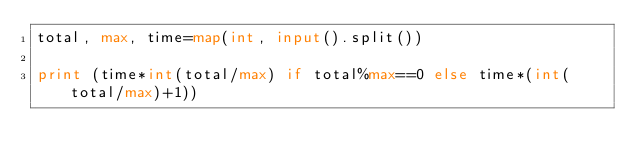Convert code to text. <code><loc_0><loc_0><loc_500><loc_500><_Python_>total, max, time=map(int, input().split())

print (time*int(total/max) if total%max==0 else time*(int(total/max)+1))
</code> 